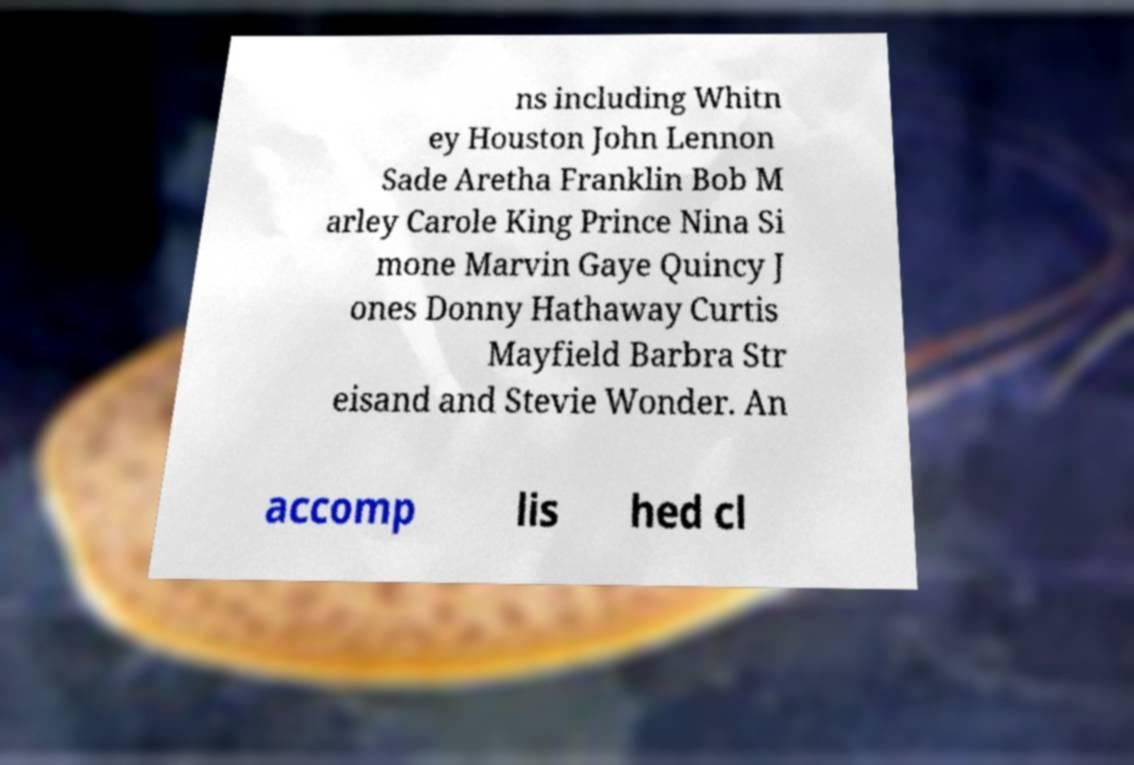Could you extract and type out the text from this image? ns including Whitn ey Houston John Lennon Sade Aretha Franklin Bob M arley Carole King Prince Nina Si mone Marvin Gaye Quincy J ones Donny Hathaway Curtis Mayfield Barbra Str eisand and Stevie Wonder. An accomp lis hed cl 